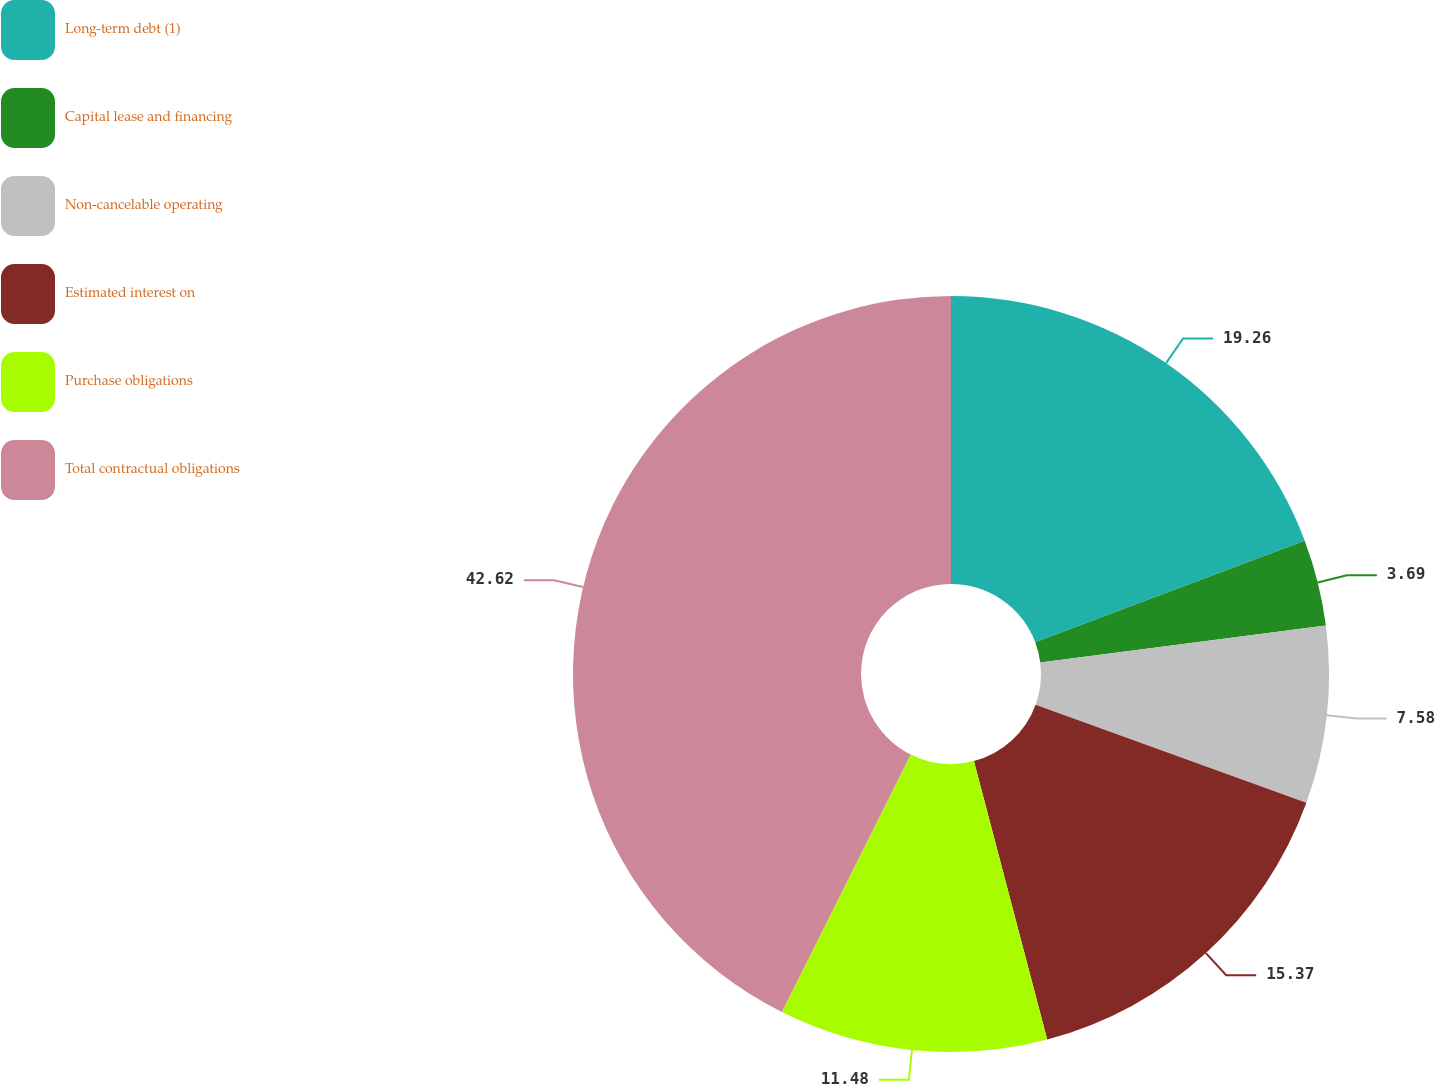<chart> <loc_0><loc_0><loc_500><loc_500><pie_chart><fcel>Long-term debt (1)<fcel>Capital lease and financing<fcel>Non-cancelable operating<fcel>Estimated interest on<fcel>Purchase obligations<fcel>Total contractual obligations<nl><fcel>19.26%<fcel>3.69%<fcel>7.58%<fcel>15.37%<fcel>11.48%<fcel>42.61%<nl></chart> 